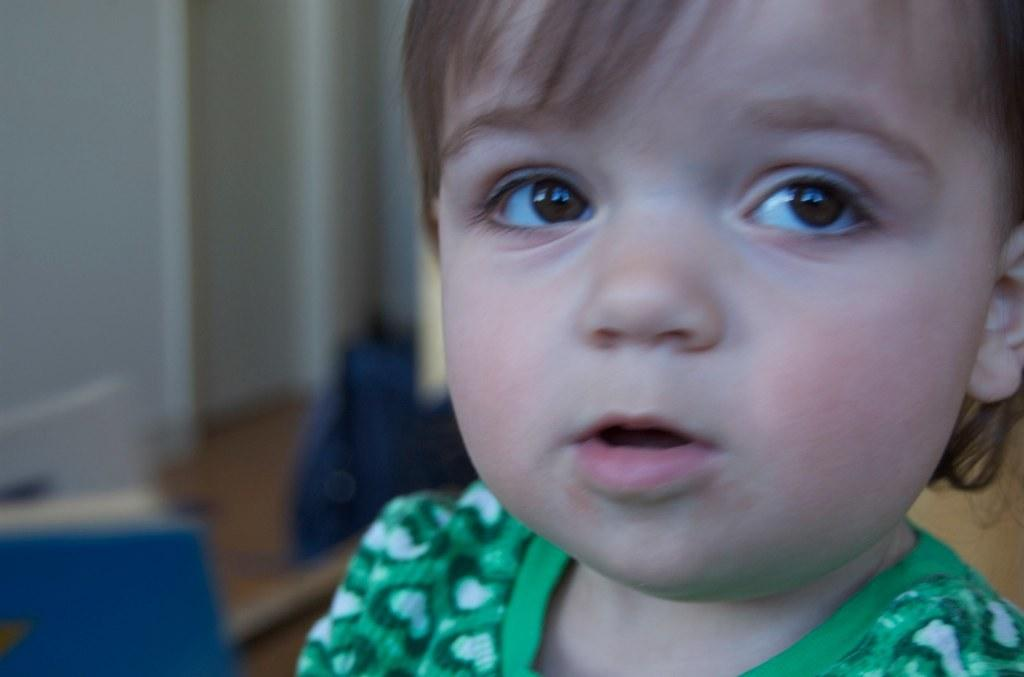What is the main subject of the image? There is a child in the image. Can you describe any objects near the child? There are a few objects beside the child, but their nature is unclear. What can be seen in the background of the image? There is a wall in the background of the image. What type of yoke is the child using to plough the field in the image? There is no yoke or plough present in the image; it features a child with unclear objects nearby. Can you tell me how many lawyers are visible in the image? There are no lawyers present in the image; it features a child with unclear objects nearby and a wall in the background. 